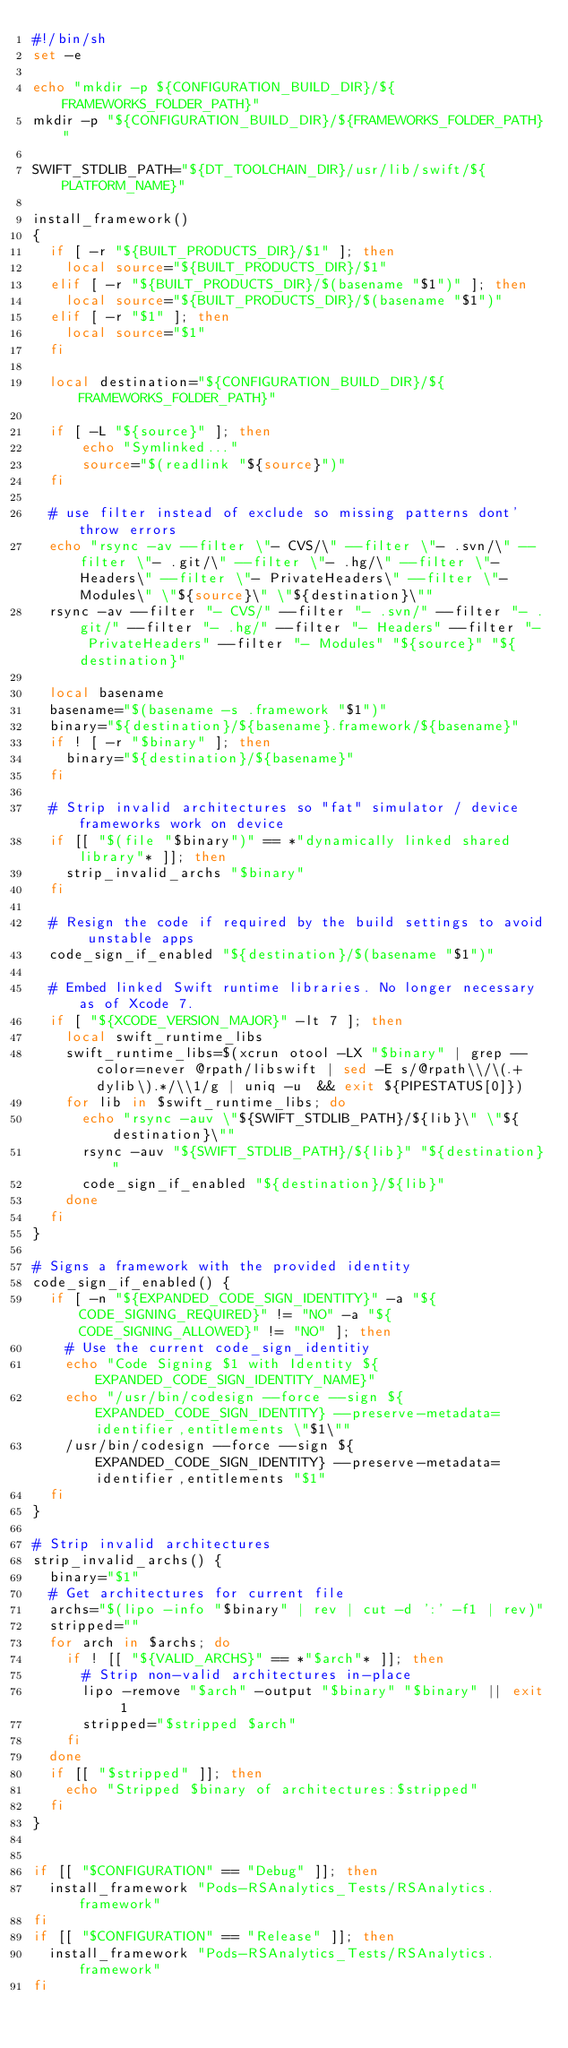Convert code to text. <code><loc_0><loc_0><loc_500><loc_500><_Bash_>#!/bin/sh
set -e

echo "mkdir -p ${CONFIGURATION_BUILD_DIR}/${FRAMEWORKS_FOLDER_PATH}"
mkdir -p "${CONFIGURATION_BUILD_DIR}/${FRAMEWORKS_FOLDER_PATH}"

SWIFT_STDLIB_PATH="${DT_TOOLCHAIN_DIR}/usr/lib/swift/${PLATFORM_NAME}"

install_framework()
{
  if [ -r "${BUILT_PRODUCTS_DIR}/$1" ]; then
    local source="${BUILT_PRODUCTS_DIR}/$1"
  elif [ -r "${BUILT_PRODUCTS_DIR}/$(basename "$1")" ]; then
    local source="${BUILT_PRODUCTS_DIR}/$(basename "$1")"
  elif [ -r "$1" ]; then
    local source="$1"
  fi

  local destination="${CONFIGURATION_BUILD_DIR}/${FRAMEWORKS_FOLDER_PATH}"

  if [ -L "${source}" ]; then
      echo "Symlinked..."
      source="$(readlink "${source}")"
  fi

  # use filter instead of exclude so missing patterns dont' throw errors
  echo "rsync -av --filter \"- CVS/\" --filter \"- .svn/\" --filter \"- .git/\" --filter \"- .hg/\" --filter \"- Headers\" --filter \"- PrivateHeaders\" --filter \"- Modules\" \"${source}\" \"${destination}\""
  rsync -av --filter "- CVS/" --filter "- .svn/" --filter "- .git/" --filter "- .hg/" --filter "- Headers" --filter "- PrivateHeaders" --filter "- Modules" "${source}" "${destination}"

  local basename
  basename="$(basename -s .framework "$1")"
  binary="${destination}/${basename}.framework/${basename}"
  if ! [ -r "$binary" ]; then
    binary="${destination}/${basename}"
  fi

  # Strip invalid architectures so "fat" simulator / device frameworks work on device
  if [[ "$(file "$binary")" == *"dynamically linked shared library"* ]]; then
    strip_invalid_archs "$binary"
  fi

  # Resign the code if required by the build settings to avoid unstable apps
  code_sign_if_enabled "${destination}/$(basename "$1")"

  # Embed linked Swift runtime libraries. No longer necessary as of Xcode 7.
  if [ "${XCODE_VERSION_MAJOR}" -lt 7 ]; then
    local swift_runtime_libs
    swift_runtime_libs=$(xcrun otool -LX "$binary" | grep --color=never @rpath/libswift | sed -E s/@rpath\\/\(.+dylib\).*/\\1/g | uniq -u  && exit ${PIPESTATUS[0]})
    for lib in $swift_runtime_libs; do
      echo "rsync -auv \"${SWIFT_STDLIB_PATH}/${lib}\" \"${destination}\""
      rsync -auv "${SWIFT_STDLIB_PATH}/${lib}" "${destination}"
      code_sign_if_enabled "${destination}/${lib}"
    done
  fi
}

# Signs a framework with the provided identity
code_sign_if_enabled() {
  if [ -n "${EXPANDED_CODE_SIGN_IDENTITY}" -a "${CODE_SIGNING_REQUIRED}" != "NO" -a "${CODE_SIGNING_ALLOWED}" != "NO" ]; then
    # Use the current code_sign_identitiy
    echo "Code Signing $1 with Identity ${EXPANDED_CODE_SIGN_IDENTITY_NAME}"
    echo "/usr/bin/codesign --force --sign ${EXPANDED_CODE_SIGN_IDENTITY} --preserve-metadata=identifier,entitlements \"$1\""
    /usr/bin/codesign --force --sign ${EXPANDED_CODE_SIGN_IDENTITY} --preserve-metadata=identifier,entitlements "$1"
  fi
}

# Strip invalid architectures
strip_invalid_archs() {
  binary="$1"
  # Get architectures for current file
  archs="$(lipo -info "$binary" | rev | cut -d ':' -f1 | rev)"
  stripped=""
  for arch in $archs; do
    if ! [[ "${VALID_ARCHS}" == *"$arch"* ]]; then
      # Strip non-valid architectures in-place
      lipo -remove "$arch" -output "$binary" "$binary" || exit 1
      stripped="$stripped $arch"
    fi
  done
  if [[ "$stripped" ]]; then
    echo "Stripped $binary of architectures:$stripped"
  fi
}


if [[ "$CONFIGURATION" == "Debug" ]]; then
  install_framework "Pods-RSAnalytics_Tests/RSAnalytics.framework"
fi
if [[ "$CONFIGURATION" == "Release" ]]; then
  install_framework "Pods-RSAnalytics_Tests/RSAnalytics.framework"
fi
</code> 